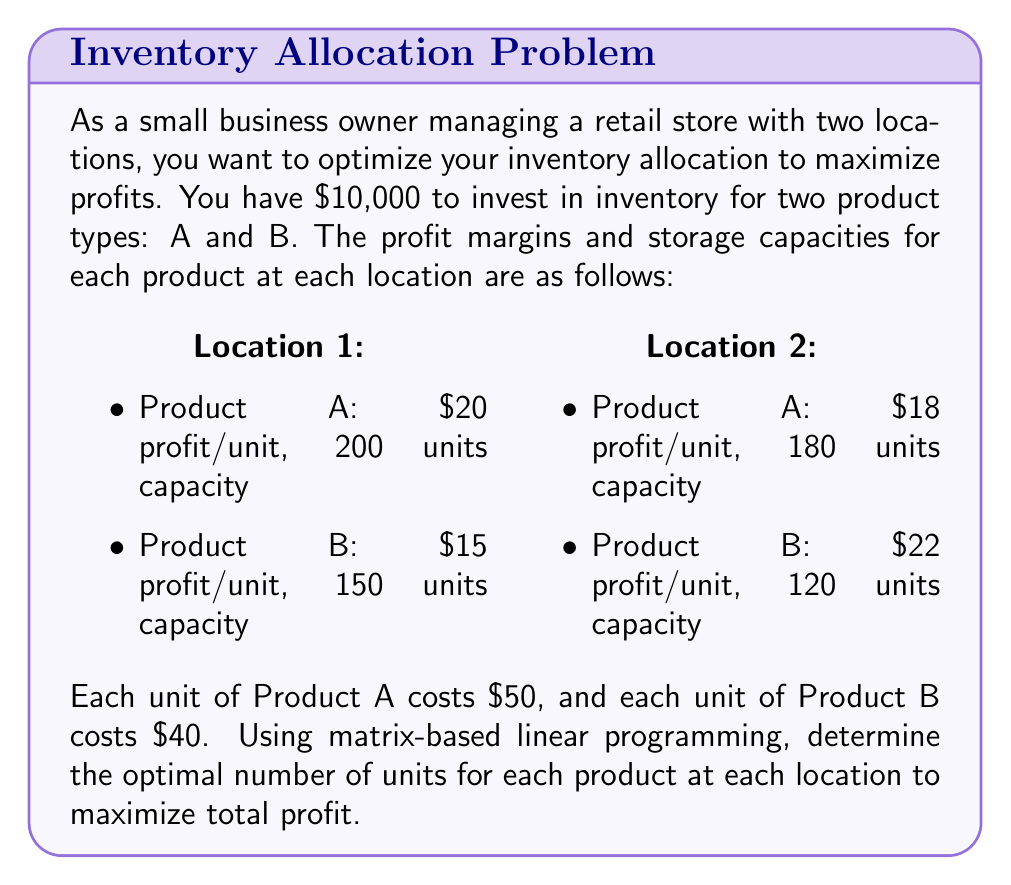Help me with this question. Let's approach this step-by-step using matrix-based linear programming:

1) Define variables:
   $x_1$ = units of Product A at Location 1
   $x_2$ = units of Product B at Location 1
   $x_3$ = units of Product A at Location 2
   $x_4$ = units of Product B at Location 2

2) Objective function (to maximize):
   $Z = 20x_1 + 15x_2 + 18x_3 + 22x_4$

3) Constraints:
   a) Capacity constraints:
      Location 1: $x_1 \leq 200$, $x_2 \leq 150$
      Location 2: $x_3 \leq 180$, $x_4 \leq 120$
   
   b) Budget constraint:
      $50x_1 + 40x_2 + 50x_3 + 40x_4 \leq 10000$

4) Non-negativity constraints:
   $x_1, x_2, x_3, x_4 \geq 0$

5) Convert to standard form:
   Maximize $Z = 20x_1 + 15x_2 + 18x_3 + 22x_4$
   Subject to:
   $$\begin{bmatrix}
   1 & 0 & 0 & 0 \\
   0 & 1 & 0 & 0 \\
   0 & 0 & 1 & 0 \\
   0 & 0 & 0 & 1 \\
   50 & 40 & 50 & 40
   \end{bmatrix}
   \begin{bmatrix}
   x_1 \\ x_2 \\ x_3 \\ x_4
   \end{bmatrix}
   \leq
   \begin{bmatrix}
   200 \\ 150 \\ 180 \\ 120 \\ 10000
   \end{bmatrix}$$

6) Solve using the simplex method or linear programming software. The optimal solution is:
   $x_1 = 200$, $x_2 = 0$, $x_3 = 0$, $x_4 = 120$

7) Calculate the maximum profit:
   $Z = 20(200) + 15(0) + 18(0) + 22(120) = 6640$

Therefore, the optimal allocation is 200 units of Product A at Location 1 and 120 units of Product B at Location 2, yielding a maximum profit of $6,640.
Answer: Location 1: 200 units of Product A, 0 units of Product B
Location 2: 0 units of Product A, 120 units of Product B
Maximum profit: $6,640 